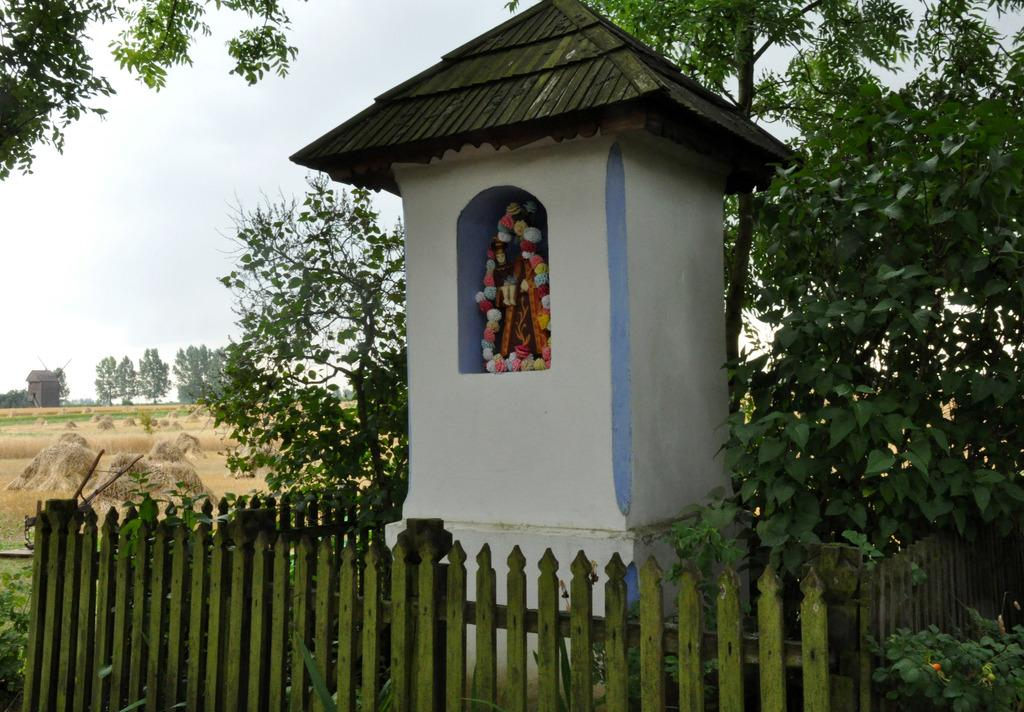What religious object can be seen in the house in the image? There is an idol of God in the house in the image. What type of barrier is present in the image? There is a fence in the image. What type of vegetation is visible in the image? There are plants and trees in the image. What type of ground cover is present in the image? There is grass on the ground. What is visible at the top of the image? The sky is visible at the top of the image. What type of wire is used to hold the wine bottle in the image? There is no wine bottle or wire present in the image. 